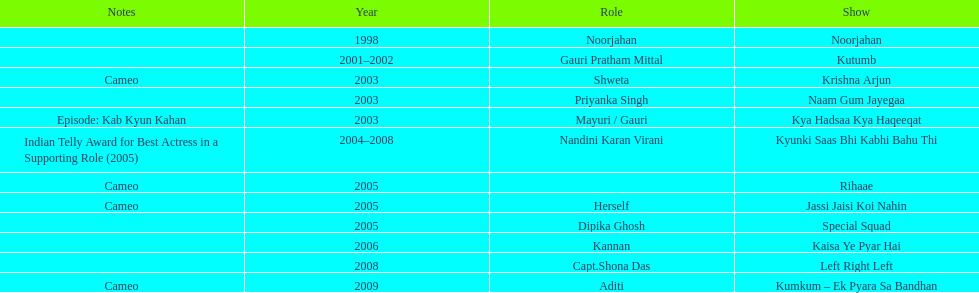Besides rihaae, in what other show did gauri tejwani cameo in 2005? Jassi Jaisi Koi Nahin. 